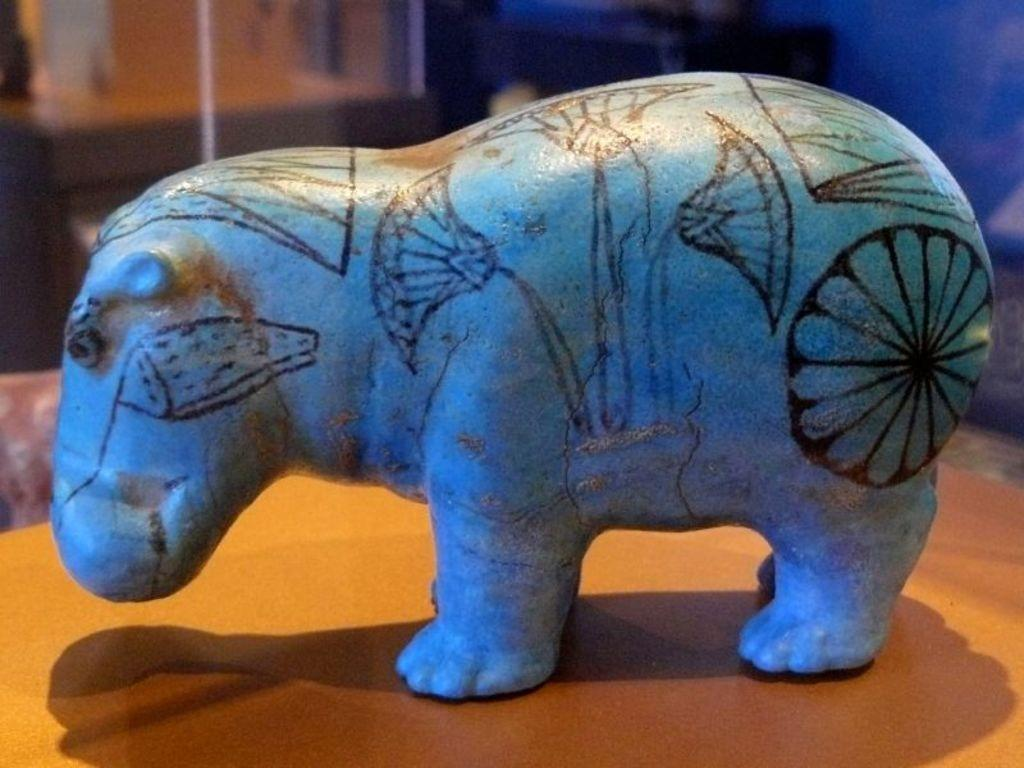What type of animal is represented by the object in the image? The object in the image is in the shape of an animal, but it is not specified which animal. What colors are used to depict the animal-shaped object? The object is blue and black in color. On what surface is the animal-shaped object placed? The object is on a cream and brown colored surface. How would you describe the background of the image? The background of the image is blurry. What type of cheese is present on the collar of the animal in the image? There is no cheese or collar present in the image; it features an animal-shaped object on a surface with a blurry background. 